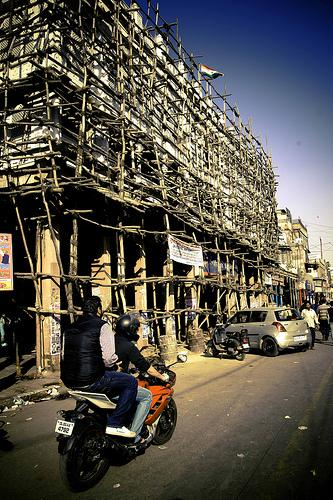Using a negative connotation, describe the presence of trash in the image. The unsightly trash pollutes the environment, cluttering the gutter with its disgusting presence. Count the number of tags that mention the color "red" in the image. There are five tags mentioning the color "red." Narrate the scene in the image as if you are a character within it. As I approached the busy street, I observed two men on a red motorcycle – one donning a helmet – speeding by. The road was littered with debris, and a large Mexican flag waved proudly in the distance. A nearby construction area caught my attention, displaying a white sign amidst the wooden structure. How many people can be seen near or in the vehicles within the image, and how many of them are wearing helmets? There are 4 people near or in the vehicles, with only one of them wearing a helmet. Identify two recreational activities that people are participating in within the image. Riding a motorcycle together and displaying a Mexican flag. Express the primary focus of the image in a poetic language. Two souls bond, a journey they embark, on wheels of red they ride, as the wind whispers secrets of joy. Share an observation about the condition of the street in the image. The road is dirty with debris and litter scattered along the gutter. Provide a description of an object in the construction area. A white sign is hanging on the structure made of sticks, indicating some sort of progress or message. What type of vehicle can be found in the image besides the motorcycle? A small gray crossover vehicle and a small silver SUV are present. Mention a specific detail regarding one of the people riding the motorcycle. The driver of the motorcycle is wearing a black helmet. How many poles are in the image and what are their colors? There are a few colorful poles. What is the color of the sneaker? White Describe the main activity involving the two people in the image. Two people are riding a red motorcycle. Identify a unique feature on the black rear fender of the motorcycle. A white license plate with black lettering. Identify a possible safety concern involving the two men on the motorcycle. Only the driver of the motorcycle is wearing a helmet. Are there any banners or signs hung around the building structure? Yes, a banner hung from scaffolding at X:149 Y:211 Width:77 Height:77 Identify an object that is red and parked on the street. A red and black motorcycle. What type of building structure is present in the image? A structure in the process of being built. Which person in the image is wearing a striped shirt? Man at position X:316 Y:299 with Width:15 Height:15 What is the sentiment of the image? Positive, Neutral, or Negative? Neutral Read the text on the white sign hanging on the structure. Unfortunately, the text on the white sign is not visible in the image. Provide captions for the different vehicles in the image. a red and black motorcycle, a dusty black scooter, a small silver SUV, tan vehicle in front of building Which objects in the image are wearing blue jeans? Men riding the red motorcycle. Locate at least two instances of debris or trash present in the scene. 1. debris in the street at X:231 Y:408 Width:78 Height:78 How many flags can be seen in the image?  2 What is the condition of the road? Dirty What is the color of the helmet being worn by one of the men on the motorcycle? Black Describe the appearance of the man that is standing behind the vehicle at coordinates X:281 Y:293. Man wearing a white shirt and blue jeans. Count the number of people in the image who are wearing helmets. 1 